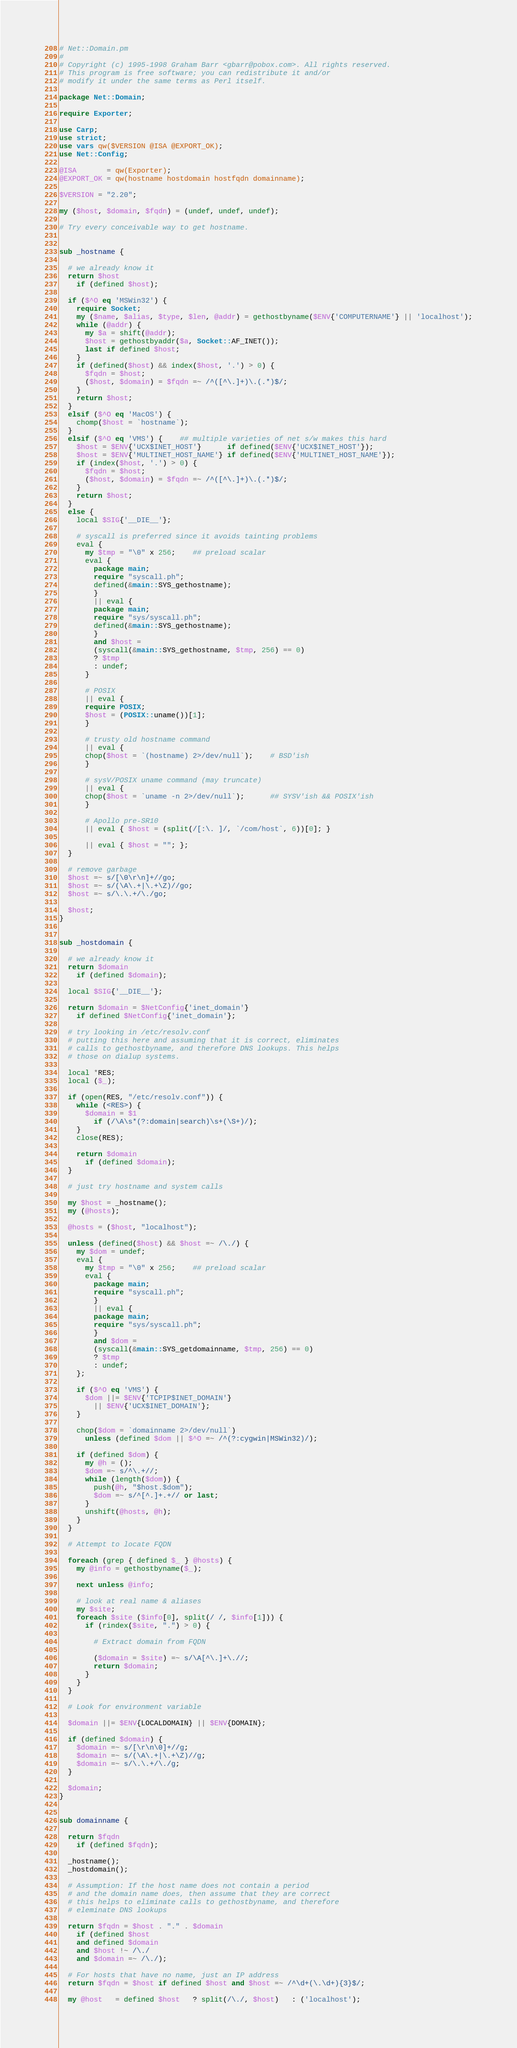Convert code to text. <code><loc_0><loc_0><loc_500><loc_500><_Perl_># Net::Domain.pm
#
# Copyright (c) 1995-1998 Graham Barr <gbarr@pobox.com>. All rights reserved.
# This program is free software; you can redistribute it and/or
# modify it under the same terms as Perl itself.

package Net::Domain;

require Exporter;

use Carp;
use strict;
use vars qw($VERSION @ISA @EXPORT_OK);
use Net::Config;

@ISA       = qw(Exporter);
@EXPORT_OK = qw(hostname hostdomain hostfqdn domainname);

$VERSION = "2.20";

my ($host, $domain, $fqdn) = (undef, undef, undef);

# Try every conceivable way to get hostname.


sub _hostname {

  # we already know it
  return $host
    if (defined $host);

  if ($^O eq 'MSWin32') {
    require Socket;
    my ($name, $alias, $type, $len, @addr) = gethostbyname($ENV{'COMPUTERNAME'} || 'localhost');
    while (@addr) {
      my $a = shift(@addr);
      $host = gethostbyaddr($a, Socket::AF_INET());
      last if defined $host;
    }
    if (defined($host) && index($host, '.') > 0) {
      $fqdn = $host;
      ($host, $domain) = $fqdn =~ /^([^\.]+)\.(.*)$/;
    }
    return $host;
  }
  elsif ($^O eq 'MacOS') {
    chomp($host = `hostname`);
  }
  elsif ($^O eq 'VMS') {    ## multiple varieties of net s/w makes this hard
    $host = $ENV{'UCX$INET_HOST'}      if defined($ENV{'UCX$INET_HOST'});
    $host = $ENV{'MULTINET_HOST_NAME'} if defined($ENV{'MULTINET_HOST_NAME'});
    if (index($host, '.') > 0) {
      $fqdn = $host;
      ($host, $domain) = $fqdn =~ /^([^\.]+)\.(.*)$/;
    }
    return $host;
  }
  else {
    local $SIG{'__DIE__'};

    # syscall is preferred since it avoids tainting problems
    eval {
      my $tmp = "\0" x 256;    ## preload scalar
      eval {
        package main;
        require "syscall.ph";
        defined(&main::SYS_gethostname);
        }
        || eval {
        package main;
        require "sys/syscall.ph";
        defined(&main::SYS_gethostname);
        }
        and $host =
        (syscall(&main::SYS_gethostname, $tmp, 256) == 0)
        ? $tmp
        : undef;
      }

      # POSIX
      || eval {
      require POSIX;
      $host = (POSIX::uname())[1];
      }

      # trusty old hostname command
      || eval {
      chop($host = `(hostname) 2>/dev/null`);    # BSD'ish
      }

      # sysV/POSIX uname command (may truncate)
      || eval {
      chop($host = `uname -n 2>/dev/null`);      ## SYSV'ish && POSIX'ish
      }

      # Apollo pre-SR10
      || eval { $host = (split(/[:\. ]/, `/com/host`, 6))[0]; }

      || eval { $host = ""; };
  }

  # remove garbage
  $host =~ s/[\0\r\n]+//go;
  $host =~ s/(\A\.+|\.+\Z)//go;
  $host =~ s/\.\.+/\./go;

  $host;
}


sub _hostdomain {

  # we already know it
  return $domain
    if (defined $domain);

  local $SIG{'__DIE__'};

  return $domain = $NetConfig{'inet_domain'}
    if defined $NetConfig{'inet_domain'};

  # try looking in /etc/resolv.conf
  # putting this here and assuming that it is correct, eliminates
  # calls to gethostbyname, and therefore DNS lookups. This helps
  # those on dialup systems.

  local *RES;
  local ($_);

  if (open(RES, "/etc/resolv.conf")) {
    while (<RES>) {
      $domain = $1
        if (/\A\s*(?:domain|search)\s+(\S+)/);
    }
    close(RES);

    return $domain
      if (defined $domain);
  }

  # just try hostname and system calls

  my $host = _hostname();
  my (@hosts);

  @hosts = ($host, "localhost");

  unless (defined($host) && $host =~ /\./) {
    my $dom = undef;
    eval {
      my $tmp = "\0" x 256;    ## preload scalar
      eval {
        package main;
        require "syscall.ph";
        }
        || eval {
        package main;
        require "sys/syscall.ph";
        }
        and $dom =
        (syscall(&main::SYS_getdomainname, $tmp, 256) == 0)
        ? $tmp
        : undef;
    };

    if ($^O eq 'VMS') {
      $dom ||= $ENV{'TCPIP$INET_DOMAIN'}
        || $ENV{'UCX$INET_DOMAIN'};
    }

    chop($dom = `domainname 2>/dev/null`)
      unless (defined $dom || $^O =~ /^(?:cygwin|MSWin32)/);

    if (defined $dom) {
      my @h = ();
      $dom =~ s/^\.+//;
      while (length($dom)) {
        push(@h, "$host.$dom");
        $dom =~ s/^[^.]+.+// or last;
      }
      unshift(@hosts, @h);
    }
  }

  # Attempt to locate FQDN

  foreach (grep { defined $_ } @hosts) {
    my @info = gethostbyname($_);

    next unless @info;

    # look at real name & aliases
    my $site;
    foreach $site ($info[0], split(/ /, $info[1])) {
      if (rindex($site, ".") > 0) {

        # Extract domain from FQDN

        ($domain = $site) =~ s/\A[^\.]+\.//;
        return $domain;
      }
    }
  }

  # Look for environment variable

  $domain ||= $ENV{LOCALDOMAIN} || $ENV{DOMAIN};

  if (defined $domain) {
    $domain =~ s/[\r\n\0]+//g;
    $domain =~ s/(\A\.+|\.+\Z)//g;
    $domain =~ s/\.\.+/\./g;
  }

  $domain;
}


sub domainname {

  return $fqdn
    if (defined $fqdn);

  _hostname();
  _hostdomain();

  # Assumption: If the host name does not contain a period
  # and the domain name does, then assume that they are correct
  # this helps to eliminate calls to gethostbyname, and therefore
  # eleminate DNS lookups

  return $fqdn = $host . "." . $domain
    if (defined $host
    and defined $domain
    and $host !~ /\./
    and $domain =~ /\./);

  # For hosts that have no name, just an IP address
  return $fqdn = $host if defined $host and $host =~ /^\d+(\.\d+){3}$/;

  my @host   = defined $host   ? split(/\./, $host)   : ('localhost');</code> 